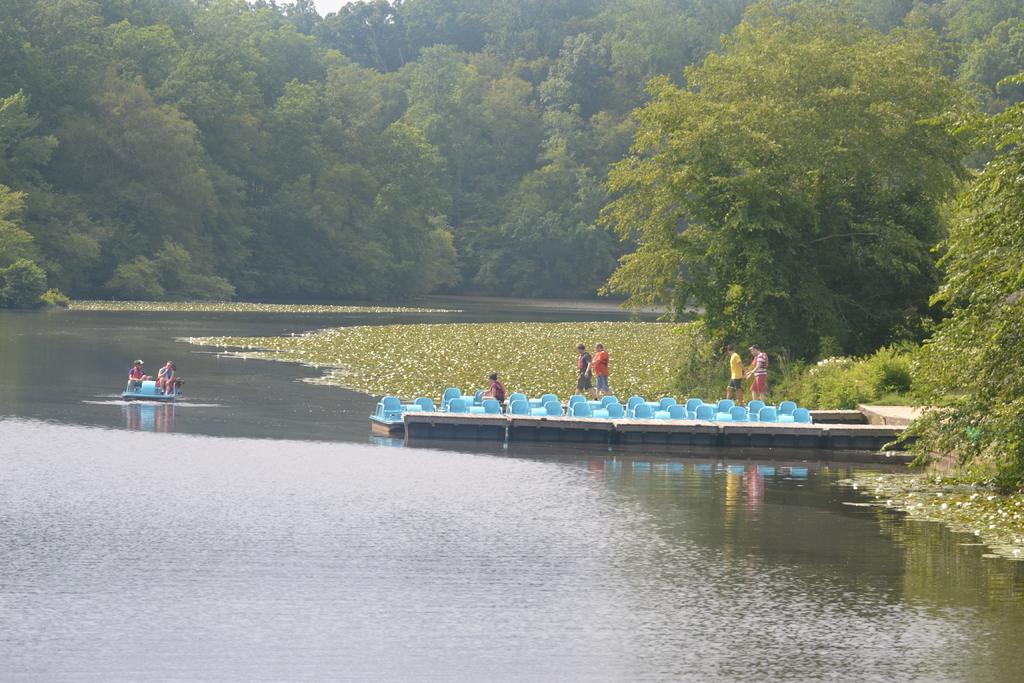Describe this image in one or two sentences. On the left side, there are two persons in a boat. This boat is on a water of a river. On the right side, there are persons in a boat and there are trees and plants on a ground. In the background, there are trees, there are plants in the water and there is sky. 